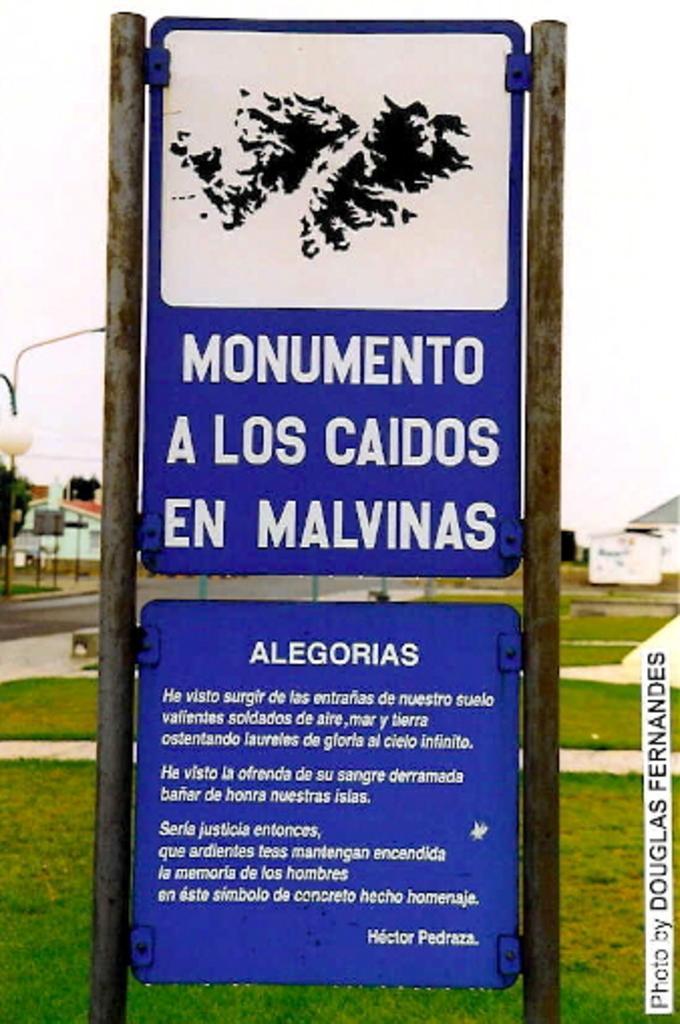Describe this image in one or two sentences. In the image there is a board, it is displaying some instructions and behind the board there is a lot of grass and on the left side there is a house and a street light. 